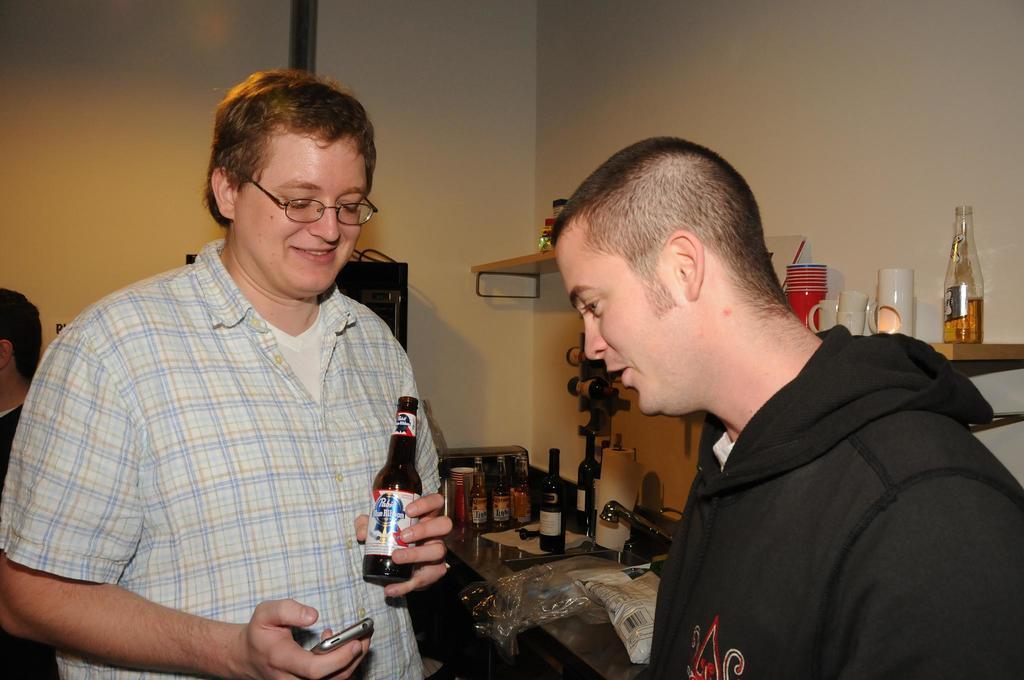In one or two sentences, can you explain what this image depicts? There are two men in this picture. One guy is holding a bottle in his hand. He is wearing a spectacles. In the background there is a table on which some bottles were placed. We can observe a wall here. 